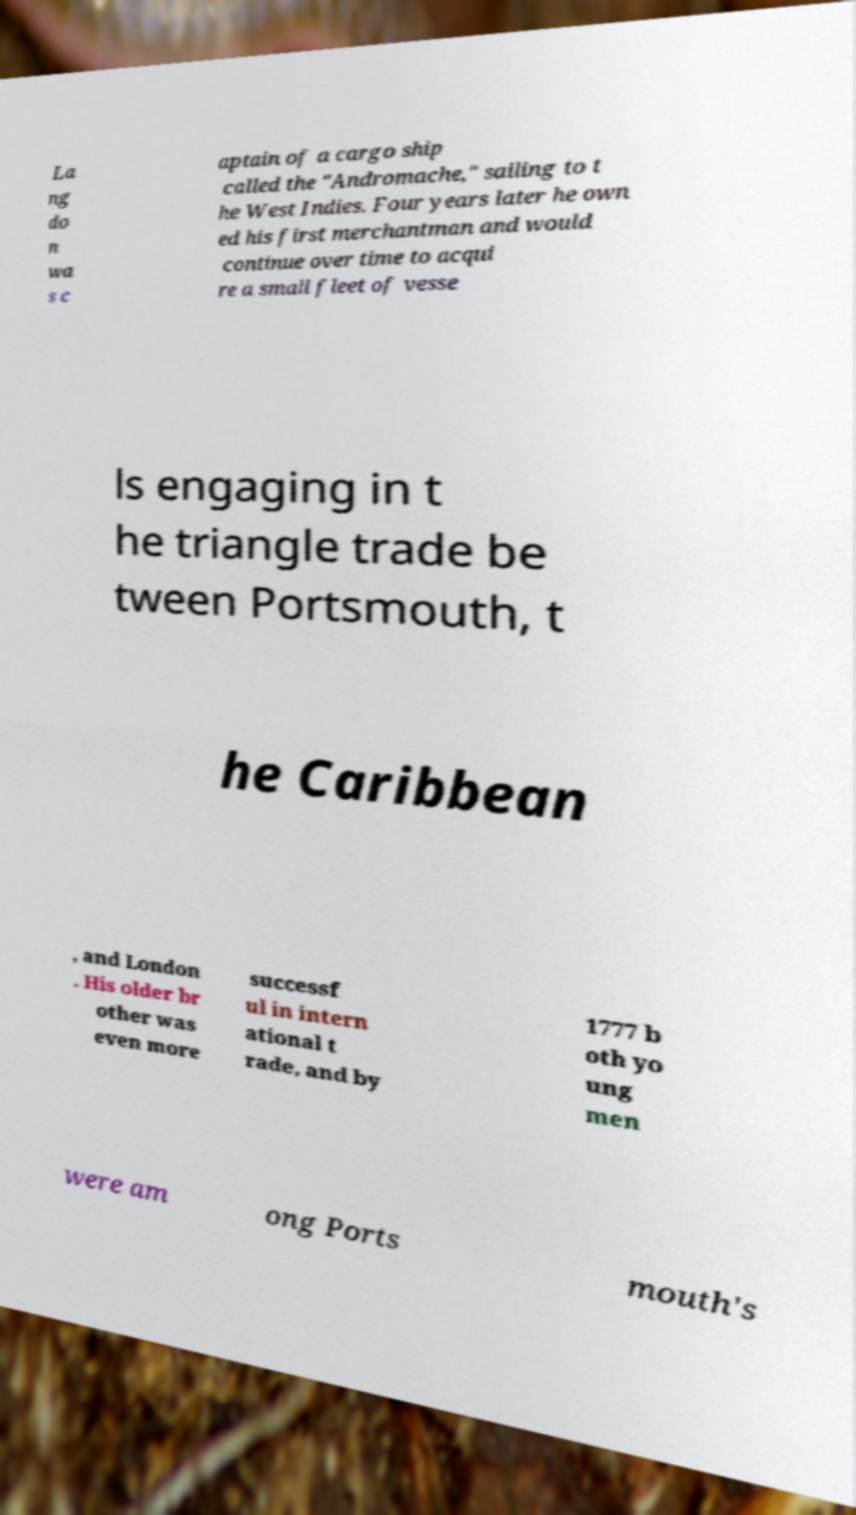For documentation purposes, I need the text within this image transcribed. Could you provide that? La ng do n wa s c aptain of a cargo ship called the "Andromache," sailing to t he West Indies. Four years later he own ed his first merchantman and would continue over time to acqui re a small fleet of vesse ls engaging in t he triangle trade be tween Portsmouth, t he Caribbean , and London . His older br other was even more successf ul in intern ational t rade, and by 1777 b oth yo ung men were am ong Ports mouth's 